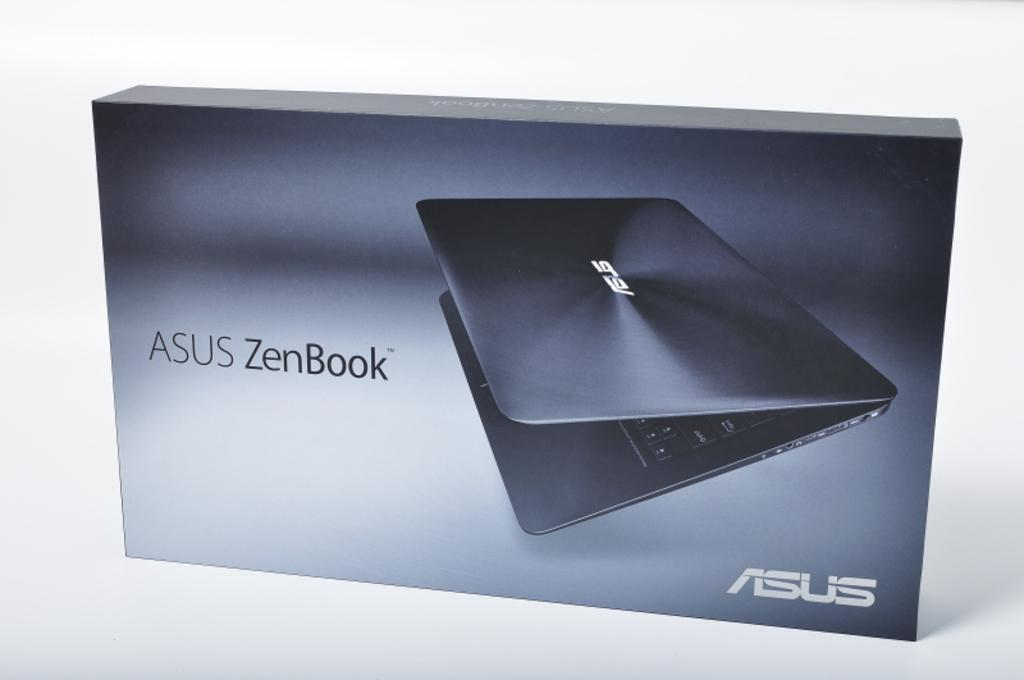<image>
Relay a brief, clear account of the picture shown. a computer box that says 'asus zenbook' on it 